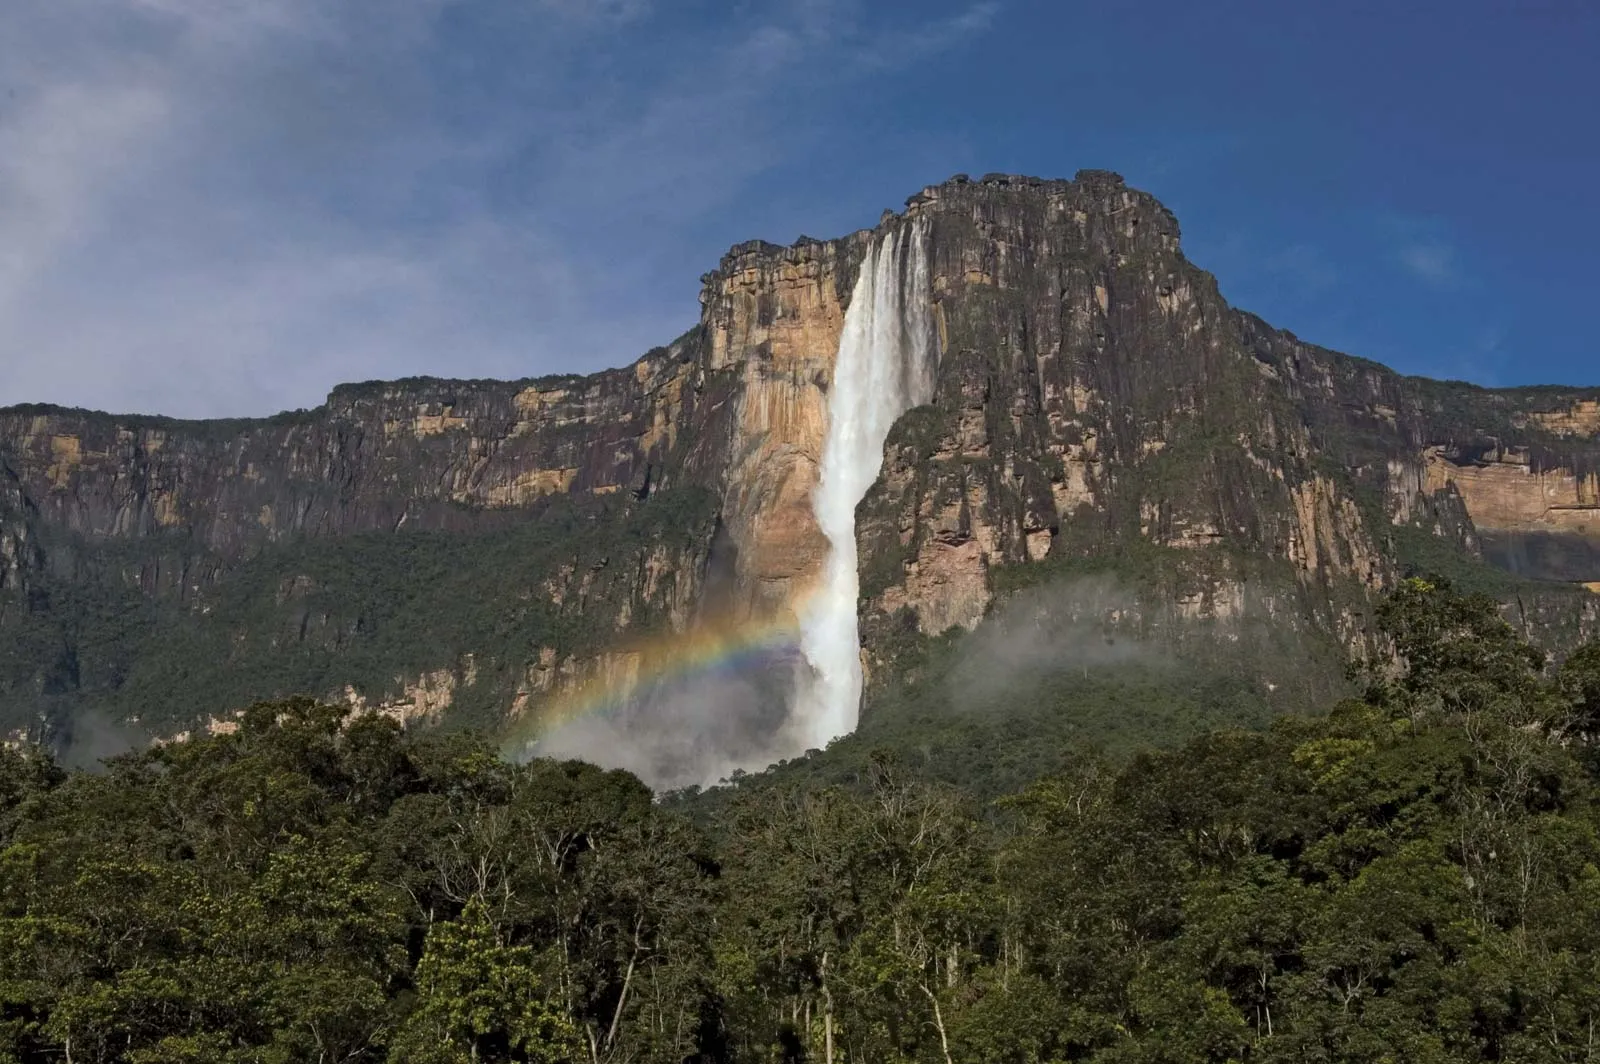What cultural significance does Angel Falls hold for the local people? Angel Falls, known as 'Kerepakupai Merú' in the indigenous Pemon language, holds profound cultural and spiritual significance for the local people. The Pemon people view the waterfall as a sacred site, connected to their ancestral spirits and the natural world. According to their legends, the waterfall is guarded by ancient spirits, and its waters are considered a source of life and purity. The falls are often featured in local storytelling, rituals, and folklore, symbolizing the immense power and beauty of nature. This deep cultural connection underscores the importance of preserving the natural environment and respecting the spiritual traditions that have been passed down through generations. How would you describe the geological formation that created Angel Falls? Angel Falls is a prime example of the geological majesty found in the Guayanese Shield, one of the oldest geological formations on Earth. The falls are part of the Auyán-tepui, a massive table-top mountain or 'tepui' made of ancient sandstone. Over millions of years, erosion by wind and water carved out dramatic cliffs and valleys, leading to the creation of these vertical precipices. Angel Falls occurs where water from the river plummets over the edge of the tepui, continuing its journey more than 3,200 feet down to the base. The unique formation of tepuis combined with the tropical climate creates a stunning natural wonder that attracts geologists and nature enthusiasts from around the world. If you could plant a fictional story in this setting, what would it be about? In the heart of Venezuela's rainforest, hidden legends come to life around Angel Falls. The locals whisper of 'The Lost Scrolls of Tepui,' an ancient manuscript believed to reveal the secrets of eternal youth. This story follows a young archaeologist named Elena, who, driven by her grandfather's tales, embarks on a perilous journey to uncover these secrets. As she traverses the dense jungle, faces natural obstacles, and deciphers cryptic messages, she forms a bond with the Pemon people, uncovering ancient rituals and wisdom. Alongside a mysterious guardian of the falls, she encounters mythical creatures and hidden realms, ultimately discovering that the true secret lies not in the scrolls, but in living harmoniously with nature and preserving its timeless beauty. 